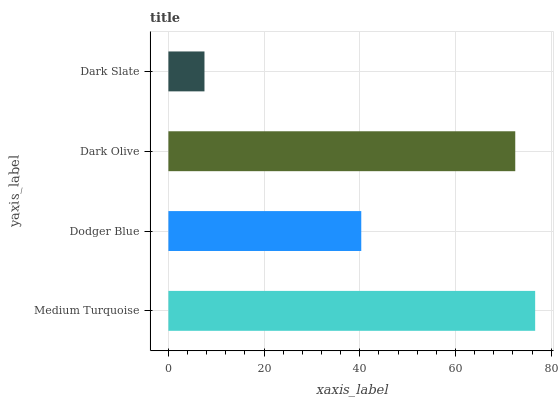Is Dark Slate the minimum?
Answer yes or no. Yes. Is Medium Turquoise the maximum?
Answer yes or no. Yes. Is Dodger Blue the minimum?
Answer yes or no. No. Is Dodger Blue the maximum?
Answer yes or no. No. Is Medium Turquoise greater than Dodger Blue?
Answer yes or no. Yes. Is Dodger Blue less than Medium Turquoise?
Answer yes or no. Yes. Is Dodger Blue greater than Medium Turquoise?
Answer yes or no. No. Is Medium Turquoise less than Dodger Blue?
Answer yes or no. No. Is Dark Olive the high median?
Answer yes or no. Yes. Is Dodger Blue the low median?
Answer yes or no. Yes. Is Dodger Blue the high median?
Answer yes or no. No. Is Dark Slate the low median?
Answer yes or no. No. 